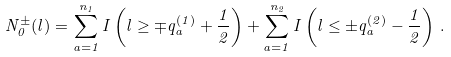<formula> <loc_0><loc_0><loc_500><loc_500>N _ { 0 } ^ { \pm } ( l ) = \sum _ { a = 1 } ^ { n _ { 1 } } I \left ( l \geq \mp q ^ { ( 1 ) } _ { a } + \frac { 1 } { 2 } \right ) + \sum _ { a = 1 } ^ { n _ { 2 } } I \left ( l \leq \pm q ^ { ( 2 ) } _ { a } - \frac { 1 } { 2 } \right ) \, .</formula> 